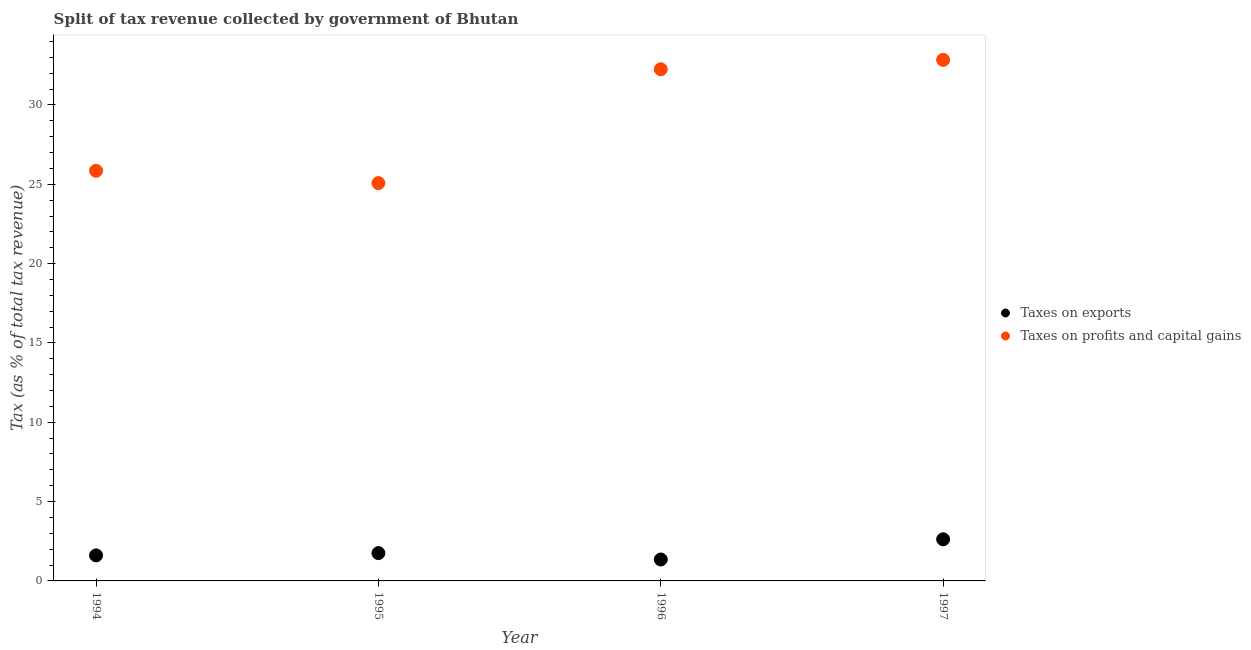What is the percentage of revenue obtained from taxes on profits and capital gains in 1994?
Provide a succinct answer. 25.85. Across all years, what is the maximum percentage of revenue obtained from taxes on profits and capital gains?
Offer a very short reply. 32.84. Across all years, what is the minimum percentage of revenue obtained from taxes on profits and capital gains?
Your answer should be compact. 25.08. What is the total percentage of revenue obtained from taxes on profits and capital gains in the graph?
Offer a very short reply. 116.02. What is the difference between the percentage of revenue obtained from taxes on exports in 1994 and that in 1996?
Offer a terse response. 0.26. What is the difference between the percentage of revenue obtained from taxes on profits and capital gains in 1997 and the percentage of revenue obtained from taxes on exports in 1996?
Provide a short and direct response. 31.49. What is the average percentage of revenue obtained from taxes on exports per year?
Provide a short and direct response. 1.83. In the year 1994, what is the difference between the percentage of revenue obtained from taxes on exports and percentage of revenue obtained from taxes on profits and capital gains?
Provide a short and direct response. -24.24. What is the ratio of the percentage of revenue obtained from taxes on profits and capital gains in 1994 to that in 1995?
Ensure brevity in your answer.  1.03. Is the difference between the percentage of revenue obtained from taxes on exports in 1995 and 1996 greater than the difference between the percentage of revenue obtained from taxes on profits and capital gains in 1995 and 1996?
Give a very brief answer. Yes. What is the difference between the highest and the second highest percentage of revenue obtained from taxes on profits and capital gains?
Ensure brevity in your answer.  0.59. What is the difference between the highest and the lowest percentage of revenue obtained from taxes on exports?
Your answer should be very brief. 1.27. Is the percentage of revenue obtained from taxes on exports strictly less than the percentage of revenue obtained from taxes on profits and capital gains over the years?
Provide a short and direct response. Yes. How many years are there in the graph?
Offer a very short reply. 4. What is the difference between two consecutive major ticks on the Y-axis?
Offer a very short reply. 5. Are the values on the major ticks of Y-axis written in scientific E-notation?
Give a very brief answer. No. How many legend labels are there?
Your answer should be compact. 2. What is the title of the graph?
Provide a succinct answer. Split of tax revenue collected by government of Bhutan. Does "From human activities" appear as one of the legend labels in the graph?
Ensure brevity in your answer.  No. What is the label or title of the Y-axis?
Ensure brevity in your answer.  Tax (as % of total tax revenue). What is the Tax (as % of total tax revenue) in Taxes on exports in 1994?
Make the answer very short. 1.61. What is the Tax (as % of total tax revenue) of Taxes on profits and capital gains in 1994?
Offer a very short reply. 25.85. What is the Tax (as % of total tax revenue) in Taxes on exports in 1995?
Offer a very short reply. 1.75. What is the Tax (as % of total tax revenue) of Taxes on profits and capital gains in 1995?
Make the answer very short. 25.08. What is the Tax (as % of total tax revenue) in Taxes on exports in 1996?
Keep it short and to the point. 1.35. What is the Tax (as % of total tax revenue) of Taxes on profits and capital gains in 1996?
Ensure brevity in your answer.  32.25. What is the Tax (as % of total tax revenue) in Taxes on exports in 1997?
Keep it short and to the point. 2.62. What is the Tax (as % of total tax revenue) of Taxes on profits and capital gains in 1997?
Ensure brevity in your answer.  32.84. Across all years, what is the maximum Tax (as % of total tax revenue) in Taxes on exports?
Provide a short and direct response. 2.62. Across all years, what is the maximum Tax (as % of total tax revenue) in Taxes on profits and capital gains?
Your answer should be compact. 32.84. Across all years, what is the minimum Tax (as % of total tax revenue) of Taxes on exports?
Give a very brief answer. 1.35. Across all years, what is the minimum Tax (as % of total tax revenue) in Taxes on profits and capital gains?
Offer a terse response. 25.08. What is the total Tax (as % of total tax revenue) in Taxes on exports in the graph?
Make the answer very short. 7.34. What is the total Tax (as % of total tax revenue) of Taxes on profits and capital gains in the graph?
Offer a very short reply. 116.02. What is the difference between the Tax (as % of total tax revenue) of Taxes on exports in 1994 and that in 1995?
Offer a very short reply. -0.14. What is the difference between the Tax (as % of total tax revenue) in Taxes on profits and capital gains in 1994 and that in 1995?
Your answer should be compact. 0.78. What is the difference between the Tax (as % of total tax revenue) in Taxes on exports in 1994 and that in 1996?
Give a very brief answer. 0.26. What is the difference between the Tax (as % of total tax revenue) of Taxes on exports in 1994 and that in 1997?
Your response must be concise. -1.01. What is the difference between the Tax (as % of total tax revenue) of Taxes on profits and capital gains in 1994 and that in 1997?
Your answer should be very brief. -6.99. What is the difference between the Tax (as % of total tax revenue) in Taxes on exports in 1995 and that in 1996?
Keep it short and to the point. 0.4. What is the difference between the Tax (as % of total tax revenue) of Taxes on profits and capital gains in 1995 and that in 1996?
Make the answer very short. -7.18. What is the difference between the Tax (as % of total tax revenue) of Taxes on exports in 1995 and that in 1997?
Ensure brevity in your answer.  -0.87. What is the difference between the Tax (as % of total tax revenue) of Taxes on profits and capital gains in 1995 and that in 1997?
Keep it short and to the point. -7.77. What is the difference between the Tax (as % of total tax revenue) in Taxes on exports in 1996 and that in 1997?
Ensure brevity in your answer.  -1.27. What is the difference between the Tax (as % of total tax revenue) of Taxes on profits and capital gains in 1996 and that in 1997?
Your answer should be very brief. -0.59. What is the difference between the Tax (as % of total tax revenue) in Taxes on exports in 1994 and the Tax (as % of total tax revenue) in Taxes on profits and capital gains in 1995?
Offer a terse response. -23.47. What is the difference between the Tax (as % of total tax revenue) of Taxes on exports in 1994 and the Tax (as % of total tax revenue) of Taxes on profits and capital gains in 1996?
Offer a terse response. -30.64. What is the difference between the Tax (as % of total tax revenue) in Taxes on exports in 1994 and the Tax (as % of total tax revenue) in Taxes on profits and capital gains in 1997?
Ensure brevity in your answer.  -31.23. What is the difference between the Tax (as % of total tax revenue) of Taxes on exports in 1995 and the Tax (as % of total tax revenue) of Taxes on profits and capital gains in 1996?
Offer a terse response. -30.5. What is the difference between the Tax (as % of total tax revenue) in Taxes on exports in 1995 and the Tax (as % of total tax revenue) in Taxes on profits and capital gains in 1997?
Provide a short and direct response. -31.09. What is the difference between the Tax (as % of total tax revenue) in Taxes on exports in 1996 and the Tax (as % of total tax revenue) in Taxes on profits and capital gains in 1997?
Provide a succinct answer. -31.49. What is the average Tax (as % of total tax revenue) in Taxes on exports per year?
Provide a short and direct response. 1.83. What is the average Tax (as % of total tax revenue) of Taxes on profits and capital gains per year?
Provide a succinct answer. 29.01. In the year 1994, what is the difference between the Tax (as % of total tax revenue) in Taxes on exports and Tax (as % of total tax revenue) in Taxes on profits and capital gains?
Make the answer very short. -24.24. In the year 1995, what is the difference between the Tax (as % of total tax revenue) in Taxes on exports and Tax (as % of total tax revenue) in Taxes on profits and capital gains?
Provide a short and direct response. -23.32. In the year 1996, what is the difference between the Tax (as % of total tax revenue) of Taxes on exports and Tax (as % of total tax revenue) of Taxes on profits and capital gains?
Offer a terse response. -30.9. In the year 1997, what is the difference between the Tax (as % of total tax revenue) of Taxes on exports and Tax (as % of total tax revenue) of Taxes on profits and capital gains?
Ensure brevity in your answer.  -30.22. What is the ratio of the Tax (as % of total tax revenue) of Taxes on exports in 1994 to that in 1995?
Ensure brevity in your answer.  0.92. What is the ratio of the Tax (as % of total tax revenue) in Taxes on profits and capital gains in 1994 to that in 1995?
Your answer should be compact. 1.03. What is the ratio of the Tax (as % of total tax revenue) in Taxes on exports in 1994 to that in 1996?
Your response must be concise. 1.19. What is the ratio of the Tax (as % of total tax revenue) in Taxes on profits and capital gains in 1994 to that in 1996?
Offer a terse response. 0.8. What is the ratio of the Tax (as % of total tax revenue) in Taxes on exports in 1994 to that in 1997?
Your answer should be compact. 0.61. What is the ratio of the Tax (as % of total tax revenue) of Taxes on profits and capital gains in 1994 to that in 1997?
Your response must be concise. 0.79. What is the ratio of the Tax (as % of total tax revenue) of Taxes on exports in 1995 to that in 1996?
Your response must be concise. 1.3. What is the ratio of the Tax (as % of total tax revenue) in Taxes on profits and capital gains in 1995 to that in 1996?
Make the answer very short. 0.78. What is the ratio of the Tax (as % of total tax revenue) in Taxes on exports in 1995 to that in 1997?
Your answer should be very brief. 0.67. What is the ratio of the Tax (as % of total tax revenue) of Taxes on profits and capital gains in 1995 to that in 1997?
Offer a very short reply. 0.76. What is the ratio of the Tax (as % of total tax revenue) in Taxes on exports in 1996 to that in 1997?
Your response must be concise. 0.51. What is the difference between the highest and the second highest Tax (as % of total tax revenue) in Taxes on exports?
Make the answer very short. 0.87. What is the difference between the highest and the second highest Tax (as % of total tax revenue) in Taxes on profits and capital gains?
Ensure brevity in your answer.  0.59. What is the difference between the highest and the lowest Tax (as % of total tax revenue) in Taxes on exports?
Ensure brevity in your answer.  1.27. What is the difference between the highest and the lowest Tax (as % of total tax revenue) in Taxes on profits and capital gains?
Offer a very short reply. 7.77. 